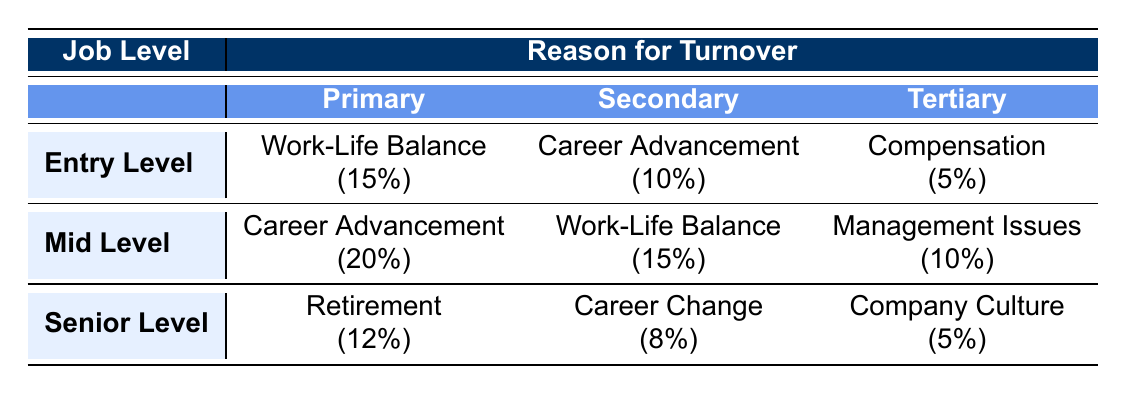What is the primary reason for turnover at the Entry Level? According to the table, the primary reason for turnover at the Entry Level is Work-Life Balance, which has a turnover rate of 15%.
Answer: Work-Life Balance What is the secondary reason for turnover at the Senior Level? The table indicates that the secondary reason for turnover at the Senior Level is Career Change, which has a turnover rate of 8%.
Answer: Career Change Which job level has the highest turnover rate for Career Advancement? The Mid Level has the highest turnover rate for Career Advancement at 20%, as shown in the table.
Answer: Mid Level What is the total turnover rate for the Mid Level? To find the total turnover rate for the Mid Level, we add the turnover rates for all reasons: 20% (Career Advancement) + 15% (Work-Life Balance) + 10% (Management Issues) = 45%.
Answer: 45% Is the compensation-related turnover rate at the Entry Level greater than at the Mid Level? The compensation-related turnover rate at the Entry Level is 5%, while the Mid Level has no compensation-related turnover indicated. Therefore, it is true that the Entry Level has a greater turnover rate related to compensation.
Answer: Yes Which job level has the lowest turnover rate for reasons listed in the table? The Senior Level has the lowest turnover rate for reasons listed, with the lowest being Company Culture at 5%.
Answer: Senior Level What percentage of Senior Level turnover is attributed to retirement? The turnover rate for retirement at the Senior Level is 12%, which is the only specific rate provided for that job level and reason in the table.
Answer: 12% If we compare the highest and lowest primary reasons for turnover across all levels, what is the difference in percentage? The highest primary reason is Career Advancement at Mid Level (20%) and the lowest primary reason is Compensation at Entry Level (5%). The difference is 20% - 5% = 15%.
Answer: 15% What percentage of turnover at the Mid Level is caused by issues with management? Management Issues caused a turnover rate of 10% at the Mid Level, directly indicated in the table.
Answer: 10% 